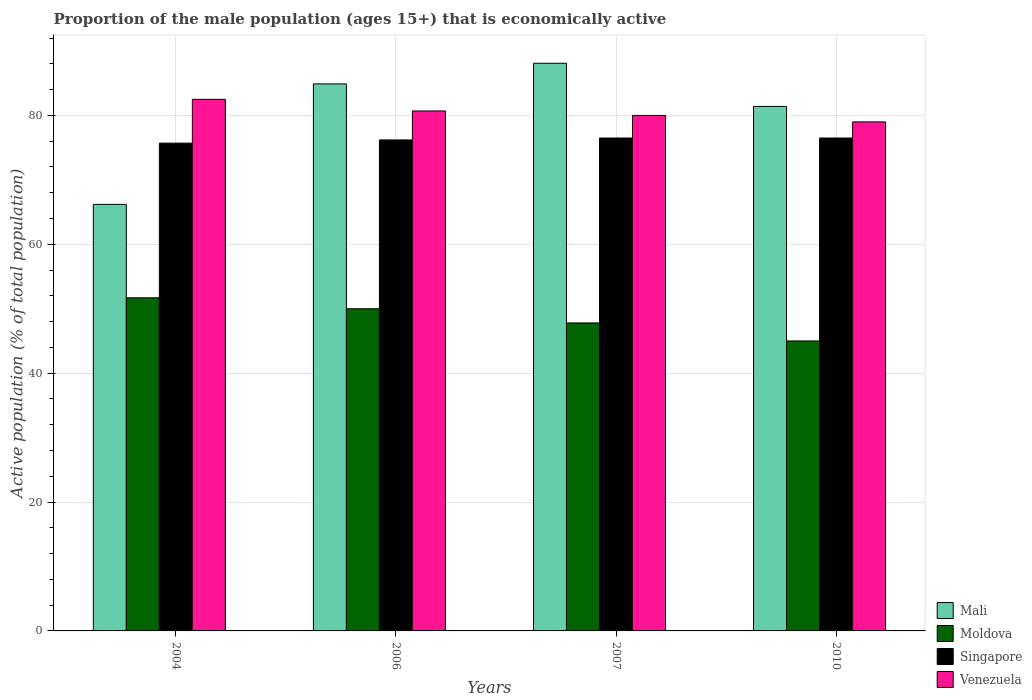Are the number of bars on each tick of the X-axis equal?
Ensure brevity in your answer.  Yes. What is the label of the 4th group of bars from the left?
Provide a succinct answer. 2010. What is the proportion of the male population that is economically active in Mali in 2006?
Make the answer very short. 84.9. Across all years, what is the maximum proportion of the male population that is economically active in Singapore?
Keep it short and to the point. 76.5. Across all years, what is the minimum proportion of the male population that is economically active in Moldova?
Offer a terse response. 45. In which year was the proportion of the male population that is economically active in Venezuela maximum?
Keep it short and to the point. 2004. In which year was the proportion of the male population that is economically active in Mali minimum?
Give a very brief answer. 2004. What is the total proportion of the male population that is economically active in Mali in the graph?
Your response must be concise. 320.6. What is the difference between the proportion of the male population that is economically active in Venezuela in 2006 and that in 2010?
Provide a succinct answer. 1.7. What is the difference between the proportion of the male population that is economically active in Singapore in 2010 and the proportion of the male population that is economically active in Venezuela in 2006?
Provide a short and direct response. -4.2. What is the average proportion of the male population that is economically active in Singapore per year?
Offer a very short reply. 76.22. In the year 2007, what is the difference between the proportion of the male population that is economically active in Singapore and proportion of the male population that is economically active in Moldova?
Make the answer very short. 28.7. In how many years, is the proportion of the male population that is economically active in Moldova greater than 80 %?
Your response must be concise. 0. What is the ratio of the proportion of the male population that is economically active in Moldova in 2007 to that in 2010?
Give a very brief answer. 1.06. Is the difference between the proportion of the male population that is economically active in Singapore in 2006 and 2010 greater than the difference between the proportion of the male population that is economically active in Moldova in 2006 and 2010?
Your answer should be compact. No. What is the difference between the highest and the second highest proportion of the male population that is economically active in Moldova?
Offer a terse response. 1.7. What is the difference between the highest and the lowest proportion of the male population that is economically active in Venezuela?
Your answer should be very brief. 3.5. What does the 1st bar from the left in 2004 represents?
Offer a very short reply. Mali. What does the 2nd bar from the right in 2007 represents?
Your answer should be compact. Singapore. Are all the bars in the graph horizontal?
Ensure brevity in your answer.  No. How many years are there in the graph?
Offer a terse response. 4. What is the difference between two consecutive major ticks on the Y-axis?
Your answer should be very brief. 20. Are the values on the major ticks of Y-axis written in scientific E-notation?
Offer a very short reply. No. Does the graph contain any zero values?
Provide a succinct answer. No. Does the graph contain grids?
Give a very brief answer. Yes. How many legend labels are there?
Provide a short and direct response. 4. How are the legend labels stacked?
Offer a very short reply. Vertical. What is the title of the graph?
Offer a very short reply. Proportion of the male population (ages 15+) that is economically active. Does "Mozambique" appear as one of the legend labels in the graph?
Ensure brevity in your answer.  No. What is the label or title of the X-axis?
Your response must be concise. Years. What is the label or title of the Y-axis?
Keep it short and to the point. Active population (% of total population). What is the Active population (% of total population) of Mali in 2004?
Give a very brief answer. 66.2. What is the Active population (% of total population) of Moldova in 2004?
Your response must be concise. 51.7. What is the Active population (% of total population) of Singapore in 2004?
Provide a succinct answer. 75.7. What is the Active population (% of total population) in Venezuela in 2004?
Your response must be concise. 82.5. What is the Active population (% of total population) of Mali in 2006?
Give a very brief answer. 84.9. What is the Active population (% of total population) of Moldova in 2006?
Keep it short and to the point. 50. What is the Active population (% of total population) of Singapore in 2006?
Your answer should be compact. 76.2. What is the Active population (% of total population) of Venezuela in 2006?
Your answer should be very brief. 80.7. What is the Active population (% of total population) in Mali in 2007?
Make the answer very short. 88.1. What is the Active population (% of total population) of Moldova in 2007?
Your response must be concise. 47.8. What is the Active population (% of total population) of Singapore in 2007?
Provide a succinct answer. 76.5. What is the Active population (% of total population) in Venezuela in 2007?
Ensure brevity in your answer.  80. What is the Active population (% of total population) in Mali in 2010?
Offer a terse response. 81.4. What is the Active population (% of total population) in Moldova in 2010?
Offer a very short reply. 45. What is the Active population (% of total population) of Singapore in 2010?
Make the answer very short. 76.5. What is the Active population (% of total population) in Venezuela in 2010?
Give a very brief answer. 79. Across all years, what is the maximum Active population (% of total population) in Mali?
Ensure brevity in your answer.  88.1. Across all years, what is the maximum Active population (% of total population) in Moldova?
Make the answer very short. 51.7. Across all years, what is the maximum Active population (% of total population) of Singapore?
Keep it short and to the point. 76.5. Across all years, what is the maximum Active population (% of total population) of Venezuela?
Provide a succinct answer. 82.5. Across all years, what is the minimum Active population (% of total population) of Mali?
Provide a short and direct response. 66.2. Across all years, what is the minimum Active population (% of total population) of Singapore?
Keep it short and to the point. 75.7. Across all years, what is the minimum Active population (% of total population) in Venezuela?
Offer a terse response. 79. What is the total Active population (% of total population) in Mali in the graph?
Keep it short and to the point. 320.6. What is the total Active population (% of total population) of Moldova in the graph?
Keep it short and to the point. 194.5. What is the total Active population (% of total population) of Singapore in the graph?
Offer a very short reply. 304.9. What is the total Active population (% of total population) in Venezuela in the graph?
Provide a succinct answer. 322.2. What is the difference between the Active population (% of total population) of Mali in 2004 and that in 2006?
Make the answer very short. -18.7. What is the difference between the Active population (% of total population) in Moldova in 2004 and that in 2006?
Give a very brief answer. 1.7. What is the difference between the Active population (% of total population) in Mali in 2004 and that in 2007?
Keep it short and to the point. -21.9. What is the difference between the Active population (% of total population) in Moldova in 2004 and that in 2007?
Your answer should be very brief. 3.9. What is the difference between the Active population (% of total population) of Singapore in 2004 and that in 2007?
Your answer should be very brief. -0.8. What is the difference between the Active population (% of total population) in Mali in 2004 and that in 2010?
Offer a very short reply. -15.2. What is the difference between the Active population (% of total population) of Venezuela in 2004 and that in 2010?
Offer a terse response. 3.5. What is the difference between the Active population (% of total population) in Venezuela in 2006 and that in 2007?
Keep it short and to the point. 0.7. What is the difference between the Active population (% of total population) of Moldova in 2006 and that in 2010?
Give a very brief answer. 5. What is the difference between the Active population (% of total population) of Venezuela in 2006 and that in 2010?
Offer a very short reply. 1.7. What is the difference between the Active population (% of total population) in Mali in 2007 and that in 2010?
Offer a terse response. 6.7. What is the difference between the Active population (% of total population) in Moldova in 2007 and that in 2010?
Offer a very short reply. 2.8. What is the difference between the Active population (% of total population) of Singapore in 2007 and that in 2010?
Provide a short and direct response. 0. What is the difference between the Active population (% of total population) in Moldova in 2004 and the Active population (% of total population) in Singapore in 2006?
Offer a very short reply. -24.5. What is the difference between the Active population (% of total population) in Moldova in 2004 and the Active population (% of total population) in Venezuela in 2006?
Make the answer very short. -29. What is the difference between the Active population (% of total population) of Singapore in 2004 and the Active population (% of total population) of Venezuela in 2006?
Give a very brief answer. -5. What is the difference between the Active population (% of total population) in Mali in 2004 and the Active population (% of total population) in Moldova in 2007?
Ensure brevity in your answer.  18.4. What is the difference between the Active population (% of total population) of Mali in 2004 and the Active population (% of total population) of Singapore in 2007?
Provide a short and direct response. -10.3. What is the difference between the Active population (% of total population) of Moldova in 2004 and the Active population (% of total population) of Singapore in 2007?
Ensure brevity in your answer.  -24.8. What is the difference between the Active population (% of total population) of Moldova in 2004 and the Active population (% of total population) of Venezuela in 2007?
Make the answer very short. -28.3. What is the difference between the Active population (% of total population) in Singapore in 2004 and the Active population (% of total population) in Venezuela in 2007?
Offer a terse response. -4.3. What is the difference between the Active population (% of total population) in Mali in 2004 and the Active population (% of total population) in Moldova in 2010?
Provide a succinct answer. 21.2. What is the difference between the Active population (% of total population) in Mali in 2004 and the Active population (% of total population) in Venezuela in 2010?
Your response must be concise. -12.8. What is the difference between the Active population (% of total population) of Moldova in 2004 and the Active population (% of total population) of Singapore in 2010?
Your answer should be very brief. -24.8. What is the difference between the Active population (% of total population) in Moldova in 2004 and the Active population (% of total population) in Venezuela in 2010?
Your answer should be very brief. -27.3. What is the difference between the Active population (% of total population) of Mali in 2006 and the Active population (% of total population) of Moldova in 2007?
Offer a terse response. 37.1. What is the difference between the Active population (% of total population) of Mali in 2006 and the Active population (% of total population) of Venezuela in 2007?
Offer a terse response. 4.9. What is the difference between the Active population (% of total population) in Moldova in 2006 and the Active population (% of total population) in Singapore in 2007?
Keep it short and to the point. -26.5. What is the difference between the Active population (% of total population) of Mali in 2006 and the Active population (% of total population) of Moldova in 2010?
Offer a terse response. 39.9. What is the difference between the Active population (% of total population) of Moldova in 2006 and the Active population (% of total population) of Singapore in 2010?
Your answer should be very brief. -26.5. What is the difference between the Active population (% of total population) in Mali in 2007 and the Active population (% of total population) in Moldova in 2010?
Offer a terse response. 43.1. What is the difference between the Active population (% of total population) of Mali in 2007 and the Active population (% of total population) of Singapore in 2010?
Offer a terse response. 11.6. What is the difference between the Active population (% of total population) in Mali in 2007 and the Active population (% of total population) in Venezuela in 2010?
Make the answer very short. 9.1. What is the difference between the Active population (% of total population) in Moldova in 2007 and the Active population (% of total population) in Singapore in 2010?
Your response must be concise. -28.7. What is the difference between the Active population (% of total population) in Moldova in 2007 and the Active population (% of total population) in Venezuela in 2010?
Your response must be concise. -31.2. What is the average Active population (% of total population) of Mali per year?
Ensure brevity in your answer.  80.15. What is the average Active population (% of total population) in Moldova per year?
Provide a succinct answer. 48.62. What is the average Active population (% of total population) in Singapore per year?
Your answer should be very brief. 76.22. What is the average Active population (% of total population) of Venezuela per year?
Make the answer very short. 80.55. In the year 2004, what is the difference between the Active population (% of total population) in Mali and Active population (% of total population) in Venezuela?
Your answer should be very brief. -16.3. In the year 2004, what is the difference between the Active population (% of total population) in Moldova and Active population (% of total population) in Singapore?
Offer a terse response. -24. In the year 2004, what is the difference between the Active population (% of total population) of Moldova and Active population (% of total population) of Venezuela?
Provide a short and direct response. -30.8. In the year 2006, what is the difference between the Active population (% of total population) of Mali and Active population (% of total population) of Moldova?
Keep it short and to the point. 34.9. In the year 2006, what is the difference between the Active population (% of total population) of Mali and Active population (% of total population) of Venezuela?
Give a very brief answer. 4.2. In the year 2006, what is the difference between the Active population (% of total population) of Moldova and Active population (% of total population) of Singapore?
Your response must be concise. -26.2. In the year 2006, what is the difference between the Active population (% of total population) of Moldova and Active population (% of total population) of Venezuela?
Your answer should be very brief. -30.7. In the year 2006, what is the difference between the Active population (% of total population) of Singapore and Active population (% of total population) of Venezuela?
Ensure brevity in your answer.  -4.5. In the year 2007, what is the difference between the Active population (% of total population) of Mali and Active population (% of total population) of Moldova?
Provide a succinct answer. 40.3. In the year 2007, what is the difference between the Active population (% of total population) of Mali and Active population (% of total population) of Singapore?
Your answer should be very brief. 11.6. In the year 2007, what is the difference between the Active population (% of total population) of Mali and Active population (% of total population) of Venezuela?
Provide a short and direct response. 8.1. In the year 2007, what is the difference between the Active population (% of total population) in Moldova and Active population (% of total population) in Singapore?
Offer a very short reply. -28.7. In the year 2007, what is the difference between the Active population (% of total population) in Moldova and Active population (% of total population) in Venezuela?
Your answer should be compact. -32.2. In the year 2010, what is the difference between the Active population (% of total population) in Mali and Active population (% of total population) in Moldova?
Your response must be concise. 36.4. In the year 2010, what is the difference between the Active population (% of total population) in Moldova and Active population (% of total population) in Singapore?
Your response must be concise. -31.5. In the year 2010, what is the difference between the Active population (% of total population) of Moldova and Active population (% of total population) of Venezuela?
Provide a short and direct response. -34. What is the ratio of the Active population (% of total population) of Mali in 2004 to that in 2006?
Your answer should be very brief. 0.78. What is the ratio of the Active population (% of total population) in Moldova in 2004 to that in 2006?
Your answer should be compact. 1.03. What is the ratio of the Active population (% of total population) in Venezuela in 2004 to that in 2006?
Provide a succinct answer. 1.02. What is the ratio of the Active population (% of total population) of Mali in 2004 to that in 2007?
Your answer should be compact. 0.75. What is the ratio of the Active population (% of total population) of Moldova in 2004 to that in 2007?
Ensure brevity in your answer.  1.08. What is the ratio of the Active population (% of total population) of Venezuela in 2004 to that in 2007?
Give a very brief answer. 1.03. What is the ratio of the Active population (% of total population) in Mali in 2004 to that in 2010?
Provide a short and direct response. 0.81. What is the ratio of the Active population (% of total population) in Moldova in 2004 to that in 2010?
Your response must be concise. 1.15. What is the ratio of the Active population (% of total population) of Venezuela in 2004 to that in 2010?
Give a very brief answer. 1.04. What is the ratio of the Active population (% of total population) in Mali in 2006 to that in 2007?
Keep it short and to the point. 0.96. What is the ratio of the Active population (% of total population) in Moldova in 2006 to that in 2007?
Your answer should be very brief. 1.05. What is the ratio of the Active population (% of total population) in Venezuela in 2006 to that in 2007?
Give a very brief answer. 1.01. What is the ratio of the Active population (% of total population) in Mali in 2006 to that in 2010?
Provide a short and direct response. 1.04. What is the ratio of the Active population (% of total population) in Singapore in 2006 to that in 2010?
Keep it short and to the point. 1. What is the ratio of the Active population (% of total population) of Venezuela in 2006 to that in 2010?
Keep it short and to the point. 1.02. What is the ratio of the Active population (% of total population) of Mali in 2007 to that in 2010?
Make the answer very short. 1.08. What is the ratio of the Active population (% of total population) of Moldova in 2007 to that in 2010?
Your response must be concise. 1.06. What is the ratio of the Active population (% of total population) of Venezuela in 2007 to that in 2010?
Make the answer very short. 1.01. What is the difference between the highest and the second highest Active population (% of total population) of Mali?
Ensure brevity in your answer.  3.2. What is the difference between the highest and the second highest Active population (% of total population) of Moldova?
Provide a short and direct response. 1.7. What is the difference between the highest and the second highest Active population (% of total population) in Venezuela?
Make the answer very short. 1.8. What is the difference between the highest and the lowest Active population (% of total population) of Mali?
Make the answer very short. 21.9. What is the difference between the highest and the lowest Active population (% of total population) of Moldova?
Provide a short and direct response. 6.7. What is the difference between the highest and the lowest Active population (% of total population) in Venezuela?
Offer a very short reply. 3.5. 